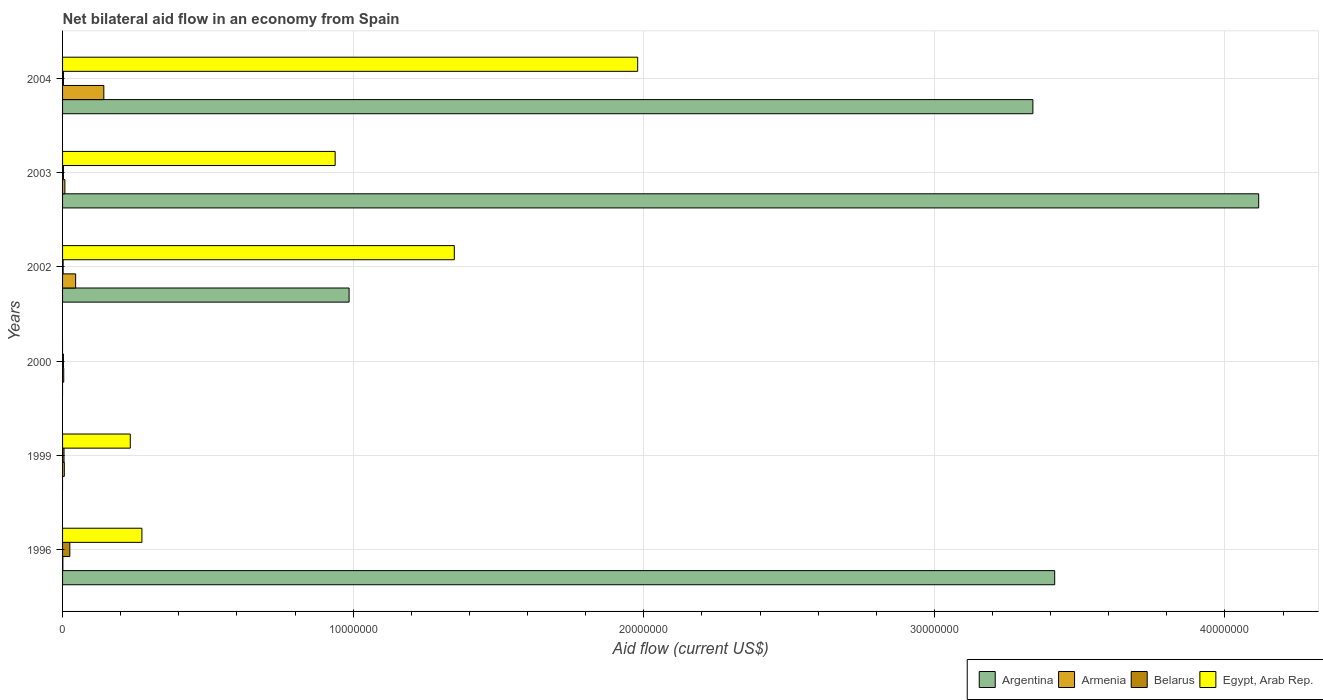How many different coloured bars are there?
Offer a very short reply. 4. Are the number of bars per tick equal to the number of legend labels?
Make the answer very short. No. How many bars are there on the 2nd tick from the bottom?
Provide a short and direct response. 3. What is the net bilateral aid flow in Belarus in 2004?
Your response must be concise. 3.00e+04. Across all years, what is the maximum net bilateral aid flow in Armenia?
Offer a terse response. 1.42e+06. In which year was the net bilateral aid flow in Egypt, Arab Rep. maximum?
Your answer should be compact. 2004. What is the total net bilateral aid flow in Egypt, Arab Rep. in the graph?
Provide a short and direct response. 4.77e+07. What is the difference between the net bilateral aid flow in Egypt, Arab Rep. in 1996 and that in 2003?
Provide a succinct answer. -6.65e+06. What is the difference between the net bilateral aid flow in Argentina in 2000 and the net bilateral aid flow in Belarus in 2003?
Provide a succinct answer. -3.00e+04. What is the average net bilateral aid flow in Egypt, Arab Rep. per year?
Offer a very short reply. 7.95e+06. In the year 2003, what is the difference between the net bilateral aid flow in Armenia and net bilateral aid flow in Egypt, Arab Rep.?
Keep it short and to the point. -9.30e+06. What is the ratio of the net bilateral aid flow in Belarus in 1999 to that in 2003?
Your answer should be very brief. 1.67. Is the net bilateral aid flow in Armenia in 2000 less than that in 2004?
Ensure brevity in your answer.  Yes. What is the difference between the highest and the second highest net bilateral aid flow in Armenia?
Give a very brief answer. 9.70e+05. What is the difference between the highest and the lowest net bilateral aid flow in Egypt, Arab Rep.?
Give a very brief answer. 1.98e+07. In how many years, is the net bilateral aid flow in Armenia greater than the average net bilateral aid flow in Armenia taken over all years?
Provide a short and direct response. 2. Is the sum of the net bilateral aid flow in Egypt, Arab Rep. in 1996 and 2003 greater than the maximum net bilateral aid flow in Argentina across all years?
Your response must be concise. No. Is it the case that in every year, the sum of the net bilateral aid flow in Belarus and net bilateral aid flow in Egypt, Arab Rep. is greater than the sum of net bilateral aid flow in Argentina and net bilateral aid flow in Armenia?
Provide a short and direct response. No. How many bars are there?
Ensure brevity in your answer.  21. Are all the bars in the graph horizontal?
Ensure brevity in your answer.  Yes. How many years are there in the graph?
Provide a short and direct response. 6. Are the values on the major ticks of X-axis written in scientific E-notation?
Make the answer very short. No. Does the graph contain any zero values?
Offer a very short reply. Yes. Where does the legend appear in the graph?
Your response must be concise. Bottom right. How many legend labels are there?
Provide a short and direct response. 4. What is the title of the graph?
Your response must be concise. Net bilateral aid flow in an economy from Spain. Does "Iraq" appear as one of the legend labels in the graph?
Provide a succinct answer. No. What is the Aid flow (current US$) in Argentina in 1996?
Offer a very short reply. 3.41e+07. What is the Aid flow (current US$) in Armenia in 1996?
Your response must be concise. 10000. What is the Aid flow (current US$) in Belarus in 1996?
Keep it short and to the point. 2.50e+05. What is the Aid flow (current US$) in Egypt, Arab Rep. in 1996?
Give a very brief answer. 2.73e+06. What is the Aid flow (current US$) of Egypt, Arab Rep. in 1999?
Offer a very short reply. 2.33e+06. What is the Aid flow (current US$) in Belarus in 2000?
Provide a succinct answer. 3.00e+04. What is the Aid flow (current US$) in Argentina in 2002?
Keep it short and to the point. 9.86e+06. What is the Aid flow (current US$) in Belarus in 2002?
Provide a short and direct response. 2.00e+04. What is the Aid flow (current US$) in Egypt, Arab Rep. in 2002?
Give a very brief answer. 1.35e+07. What is the Aid flow (current US$) of Argentina in 2003?
Ensure brevity in your answer.  4.12e+07. What is the Aid flow (current US$) of Armenia in 2003?
Ensure brevity in your answer.  8.00e+04. What is the Aid flow (current US$) of Egypt, Arab Rep. in 2003?
Offer a terse response. 9.38e+06. What is the Aid flow (current US$) in Argentina in 2004?
Your answer should be compact. 3.34e+07. What is the Aid flow (current US$) in Armenia in 2004?
Offer a terse response. 1.42e+06. What is the Aid flow (current US$) in Egypt, Arab Rep. in 2004?
Provide a short and direct response. 1.98e+07. Across all years, what is the maximum Aid flow (current US$) of Argentina?
Provide a succinct answer. 4.12e+07. Across all years, what is the maximum Aid flow (current US$) in Armenia?
Your answer should be compact. 1.42e+06. Across all years, what is the maximum Aid flow (current US$) of Belarus?
Provide a short and direct response. 2.50e+05. Across all years, what is the maximum Aid flow (current US$) of Egypt, Arab Rep.?
Your answer should be compact. 1.98e+07. Across all years, what is the minimum Aid flow (current US$) in Argentina?
Offer a very short reply. 0. Across all years, what is the minimum Aid flow (current US$) of Belarus?
Offer a very short reply. 2.00e+04. What is the total Aid flow (current US$) of Argentina in the graph?
Your answer should be very brief. 1.19e+08. What is the total Aid flow (current US$) of Armenia in the graph?
Keep it short and to the point. 2.06e+06. What is the total Aid flow (current US$) in Egypt, Arab Rep. in the graph?
Provide a short and direct response. 4.77e+07. What is the difference between the Aid flow (current US$) of Armenia in 1996 and that in 1999?
Keep it short and to the point. -5.00e+04. What is the difference between the Aid flow (current US$) in Belarus in 1996 and that in 1999?
Provide a succinct answer. 2.00e+05. What is the difference between the Aid flow (current US$) in Egypt, Arab Rep. in 1996 and that in 1999?
Provide a succinct answer. 4.00e+05. What is the difference between the Aid flow (current US$) of Armenia in 1996 and that in 2000?
Give a very brief answer. -3.00e+04. What is the difference between the Aid flow (current US$) in Belarus in 1996 and that in 2000?
Offer a very short reply. 2.20e+05. What is the difference between the Aid flow (current US$) in Argentina in 1996 and that in 2002?
Give a very brief answer. 2.43e+07. What is the difference between the Aid flow (current US$) of Armenia in 1996 and that in 2002?
Your answer should be compact. -4.40e+05. What is the difference between the Aid flow (current US$) in Egypt, Arab Rep. in 1996 and that in 2002?
Give a very brief answer. -1.08e+07. What is the difference between the Aid flow (current US$) of Argentina in 1996 and that in 2003?
Your answer should be very brief. -7.02e+06. What is the difference between the Aid flow (current US$) of Armenia in 1996 and that in 2003?
Make the answer very short. -7.00e+04. What is the difference between the Aid flow (current US$) of Belarus in 1996 and that in 2003?
Provide a succinct answer. 2.20e+05. What is the difference between the Aid flow (current US$) in Egypt, Arab Rep. in 1996 and that in 2003?
Your answer should be very brief. -6.65e+06. What is the difference between the Aid flow (current US$) in Argentina in 1996 and that in 2004?
Provide a short and direct response. 7.50e+05. What is the difference between the Aid flow (current US$) of Armenia in 1996 and that in 2004?
Your response must be concise. -1.41e+06. What is the difference between the Aid flow (current US$) in Egypt, Arab Rep. in 1996 and that in 2004?
Offer a terse response. -1.71e+07. What is the difference between the Aid flow (current US$) of Armenia in 1999 and that in 2002?
Ensure brevity in your answer.  -3.90e+05. What is the difference between the Aid flow (current US$) of Egypt, Arab Rep. in 1999 and that in 2002?
Your answer should be very brief. -1.12e+07. What is the difference between the Aid flow (current US$) in Egypt, Arab Rep. in 1999 and that in 2003?
Keep it short and to the point. -7.05e+06. What is the difference between the Aid flow (current US$) in Armenia in 1999 and that in 2004?
Offer a very short reply. -1.36e+06. What is the difference between the Aid flow (current US$) of Egypt, Arab Rep. in 1999 and that in 2004?
Give a very brief answer. -1.75e+07. What is the difference between the Aid flow (current US$) of Armenia in 2000 and that in 2002?
Provide a short and direct response. -4.10e+05. What is the difference between the Aid flow (current US$) of Armenia in 2000 and that in 2003?
Offer a very short reply. -4.00e+04. What is the difference between the Aid flow (current US$) of Armenia in 2000 and that in 2004?
Your answer should be very brief. -1.38e+06. What is the difference between the Aid flow (current US$) in Argentina in 2002 and that in 2003?
Your answer should be compact. -3.13e+07. What is the difference between the Aid flow (current US$) in Armenia in 2002 and that in 2003?
Keep it short and to the point. 3.70e+05. What is the difference between the Aid flow (current US$) of Egypt, Arab Rep. in 2002 and that in 2003?
Your response must be concise. 4.10e+06. What is the difference between the Aid flow (current US$) in Argentina in 2002 and that in 2004?
Your response must be concise. -2.35e+07. What is the difference between the Aid flow (current US$) in Armenia in 2002 and that in 2004?
Your answer should be compact. -9.70e+05. What is the difference between the Aid flow (current US$) of Belarus in 2002 and that in 2004?
Ensure brevity in your answer.  -10000. What is the difference between the Aid flow (current US$) of Egypt, Arab Rep. in 2002 and that in 2004?
Keep it short and to the point. -6.31e+06. What is the difference between the Aid flow (current US$) in Argentina in 2003 and that in 2004?
Offer a terse response. 7.77e+06. What is the difference between the Aid flow (current US$) in Armenia in 2003 and that in 2004?
Your answer should be compact. -1.34e+06. What is the difference between the Aid flow (current US$) in Egypt, Arab Rep. in 2003 and that in 2004?
Keep it short and to the point. -1.04e+07. What is the difference between the Aid flow (current US$) in Argentina in 1996 and the Aid flow (current US$) in Armenia in 1999?
Keep it short and to the point. 3.41e+07. What is the difference between the Aid flow (current US$) in Argentina in 1996 and the Aid flow (current US$) in Belarus in 1999?
Your response must be concise. 3.41e+07. What is the difference between the Aid flow (current US$) of Argentina in 1996 and the Aid flow (current US$) of Egypt, Arab Rep. in 1999?
Give a very brief answer. 3.18e+07. What is the difference between the Aid flow (current US$) of Armenia in 1996 and the Aid flow (current US$) of Egypt, Arab Rep. in 1999?
Your answer should be very brief. -2.32e+06. What is the difference between the Aid flow (current US$) in Belarus in 1996 and the Aid flow (current US$) in Egypt, Arab Rep. in 1999?
Provide a short and direct response. -2.08e+06. What is the difference between the Aid flow (current US$) of Argentina in 1996 and the Aid flow (current US$) of Armenia in 2000?
Offer a terse response. 3.41e+07. What is the difference between the Aid flow (current US$) in Argentina in 1996 and the Aid flow (current US$) in Belarus in 2000?
Offer a very short reply. 3.41e+07. What is the difference between the Aid flow (current US$) in Armenia in 1996 and the Aid flow (current US$) in Belarus in 2000?
Make the answer very short. -2.00e+04. What is the difference between the Aid flow (current US$) in Argentina in 1996 and the Aid flow (current US$) in Armenia in 2002?
Make the answer very short. 3.37e+07. What is the difference between the Aid flow (current US$) in Argentina in 1996 and the Aid flow (current US$) in Belarus in 2002?
Offer a very short reply. 3.41e+07. What is the difference between the Aid flow (current US$) in Argentina in 1996 and the Aid flow (current US$) in Egypt, Arab Rep. in 2002?
Your answer should be very brief. 2.07e+07. What is the difference between the Aid flow (current US$) in Armenia in 1996 and the Aid flow (current US$) in Belarus in 2002?
Offer a terse response. -10000. What is the difference between the Aid flow (current US$) in Armenia in 1996 and the Aid flow (current US$) in Egypt, Arab Rep. in 2002?
Offer a terse response. -1.35e+07. What is the difference between the Aid flow (current US$) in Belarus in 1996 and the Aid flow (current US$) in Egypt, Arab Rep. in 2002?
Provide a short and direct response. -1.32e+07. What is the difference between the Aid flow (current US$) in Argentina in 1996 and the Aid flow (current US$) in Armenia in 2003?
Your answer should be very brief. 3.41e+07. What is the difference between the Aid flow (current US$) in Argentina in 1996 and the Aid flow (current US$) in Belarus in 2003?
Give a very brief answer. 3.41e+07. What is the difference between the Aid flow (current US$) of Argentina in 1996 and the Aid flow (current US$) of Egypt, Arab Rep. in 2003?
Your answer should be very brief. 2.48e+07. What is the difference between the Aid flow (current US$) in Armenia in 1996 and the Aid flow (current US$) in Egypt, Arab Rep. in 2003?
Your response must be concise. -9.37e+06. What is the difference between the Aid flow (current US$) of Belarus in 1996 and the Aid flow (current US$) of Egypt, Arab Rep. in 2003?
Offer a very short reply. -9.13e+06. What is the difference between the Aid flow (current US$) in Argentina in 1996 and the Aid flow (current US$) in Armenia in 2004?
Offer a terse response. 3.27e+07. What is the difference between the Aid flow (current US$) of Argentina in 1996 and the Aid flow (current US$) of Belarus in 2004?
Give a very brief answer. 3.41e+07. What is the difference between the Aid flow (current US$) of Argentina in 1996 and the Aid flow (current US$) of Egypt, Arab Rep. in 2004?
Offer a very short reply. 1.44e+07. What is the difference between the Aid flow (current US$) of Armenia in 1996 and the Aid flow (current US$) of Belarus in 2004?
Give a very brief answer. -2.00e+04. What is the difference between the Aid flow (current US$) in Armenia in 1996 and the Aid flow (current US$) in Egypt, Arab Rep. in 2004?
Make the answer very short. -1.98e+07. What is the difference between the Aid flow (current US$) of Belarus in 1996 and the Aid flow (current US$) of Egypt, Arab Rep. in 2004?
Offer a terse response. -1.95e+07. What is the difference between the Aid flow (current US$) of Armenia in 1999 and the Aid flow (current US$) of Belarus in 2000?
Provide a short and direct response. 3.00e+04. What is the difference between the Aid flow (current US$) in Armenia in 1999 and the Aid flow (current US$) in Belarus in 2002?
Provide a short and direct response. 4.00e+04. What is the difference between the Aid flow (current US$) of Armenia in 1999 and the Aid flow (current US$) of Egypt, Arab Rep. in 2002?
Provide a short and direct response. -1.34e+07. What is the difference between the Aid flow (current US$) of Belarus in 1999 and the Aid flow (current US$) of Egypt, Arab Rep. in 2002?
Offer a terse response. -1.34e+07. What is the difference between the Aid flow (current US$) in Armenia in 1999 and the Aid flow (current US$) in Egypt, Arab Rep. in 2003?
Provide a succinct answer. -9.32e+06. What is the difference between the Aid flow (current US$) of Belarus in 1999 and the Aid flow (current US$) of Egypt, Arab Rep. in 2003?
Keep it short and to the point. -9.33e+06. What is the difference between the Aid flow (current US$) of Armenia in 1999 and the Aid flow (current US$) of Belarus in 2004?
Your answer should be compact. 3.00e+04. What is the difference between the Aid flow (current US$) of Armenia in 1999 and the Aid flow (current US$) of Egypt, Arab Rep. in 2004?
Your answer should be compact. -1.97e+07. What is the difference between the Aid flow (current US$) of Belarus in 1999 and the Aid flow (current US$) of Egypt, Arab Rep. in 2004?
Ensure brevity in your answer.  -1.97e+07. What is the difference between the Aid flow (current US$) of Armenia in 2000 and the Aid flow (current US$) of Egypt, Arab Rep. in 2002?
Offer a very short reply. -1.34e+07. What is the difference between the Aid flow (current US$) in Belarus in 2000 and the Aid flow (current US$) in Egypt, Arab Rep. in 2002?
Offer a terse response. -1.34e+07. What is the difference between the Aid flow (current US$) in Armenia in 2000 and the Aid flow (current US$) in Belarus in 2003?
Your response must be concise. 10000. What is the difference between the Aid flow (current US$) in Armenia in 2000 and the Aid flow (current US$) in Egypt, Arab Rep. in 2003?
Give a very brief answer. -9.34e+06. What is the difference between the Aid flow (current US$) in Belarus in 2000 and the Aid flow (current US$) in Egypt, Arab Rep. in 2003?
Your response must be concise. -9.35e+06. What is the difference between the Aid flow (current US$) of Armenia in 2000 and the Aid flow (current US$) of Belarus in 2004?
Give a very brief answer. 10000. What is the difference between the Aid flow (current US$) of Armenia in 2000 and the Aid flow (current US$) of Egypt, Arab Rep. in 2004?
Provide a short and direct response. -1.98e+07. What is the difference between the Aid flow (current US$) of Belarus in 2000 and the Aid flow (current US$) of Egypt, Arab Rep. in 2004?
Offer a terse response. -1.98e+07. What is the difference between the Aid flow (current US$) of Argentina in 2002 and the Aid flow (current US$) of Armenia in 2003?
Give a very brief answer. 9.78e+06. What is the difference between the Aid flow (current US$) of Argentina in 2002 and the Aid flow (current US$) of Belarus in 2003?
Your response must be concise. 9.83e+06. What is the difference between the Aid flow (current US$) of Armenia in 2002 and the Aid flow (current US$) of Belarus in 2003?
Ensure brevity in your answer.  4.20e+05. What is the difference between the Aid flow (current US$) of Armenia in 2002 and the Aid flow (current US$) of Egypt, Arab Rep. in 2003?
Make the answer very short. -8.93e+06. What is the difference between the Aid flow (current US$) in Belarus in 2002 and the Aid flow (current US$) in Egypt, Arab Rep. in 2003?
Provide a short and direct response. -9.36e+06. What is the difference between the Aid flow (current US$) in Argentina in 2002 and the Aid flow (current US$) in Armenia in 2004?
Provide a succinct answer. 8.44e+06. What is the difference between the Aid flow (current US$) in Argentina in 2002 and the Aid flow (current US$) in Belarus in 2004?
Provide a succinct answer. 9.83e+06. What is the difference between the Aid flow (current US$) in Argentina in 2002 and the Aid flow (current US$) in Egypt, Arab Rep. in 2004?
Offer a very short reply. -9.93e+06. What is the difference between the Aid flow (current US$) of Armenia in 2002 and the Aid flow (current US$) of Egypt, Arab Rep. in 2004?
Provide a succinct answer. -1.93e+07. What is the difference between the Aid flow (current US$) of Belarus in 2002 and the Aid flow (current US$) of Egypt, Arab Rep. in 2004?
Offer a very short reply. -1.98e+07. What is the difference between the Aid flow (current US$) in Argentina in 2003 and the Aid flow (current US$) in Armenia in 2004?
Give a very brief answer. 3.97e+07. What is the difference between the Aid flow (current US$) in Argentina in 2003 and the Aid flow (current US$) in Belarus in 2004?
Ensure brevity in your answer.  4.11e+07. What is the difference between the Aid flow (current US$) of Argentina in 2003 and the Aid flow (current US$) of Egypt, Arab Rep. in 2004?
Offer a terse response. 2.14e+07. What is the difference between the Aid flow (current US$) in Armenia in 2003 and the Aid flow (current US$) in Belarus in 2004?
Provide a short and direct response. 5.00e+04. What is the difference between the Aid flow (current US$) in Armenia in 2003 and the Aid flow (current US$) in Egypt, Arab Rep. in 2004?
Your answer should be very brief. -1.97e+07. What is the difference between the Aid flow (current US$) of Belarus in 2003 and the Aid flow (current US$) of Egypt, Arab Rep. in 2004?
Provide a short and direct response. -1.98e+07. What is the average Aid flow (current US$) of Argentina per year?
Keep it short and to the point. 1.98e+07. What is the average Aid flow (current US$) in Armenia per year?
Your answer should be very brief. 3.43e+05. What is the average Aid flow (current US$) of Belarus per year?
Ensure brevity in your answer.  6.83e+04. What is the average Aid flow (current US$) in Egypt, Arab Rep. per year?
Keep it short and to the point. 7.95e+06. In the year 1996, what is the difference between the Aid flow (current US$) of Argentina and Aid flow (current US$) of Armenia?
Your answer should be compact. 3.41e+07. In the year 1996, what is the difference between the Aid flow (current US$) in Argentina and Aid flow (current US$) in Belarus?
Offer a very short reply. 3.39e+07. In the year 1996, what is the difference between the Aid flow (current US$) in Argentina and Aid flow (current US$) in Egypt, Arab Rep.?
Provide a succinct answer. 3.14e+07. In the year 1996, what is the difference between the Aid flow (current US$) of Armenia and Aid flow (current US$) of Egypt, Arab Rep.?
Offer a terse response. -2.72e+06. In the year 1996, what is the difference between the Aid flow (current US$) of Belarus and Aid flow (current US$) of Egypt, Arab Rep.?
Ensure brevity in your answer.  -2.48e+06. In the year 1999, what is the difference between the Aid flow (current US$) of Armenia and Aid flow (current US$) of Egypt, Arab Rep.?
Offer a terse response. -2.27e+06. In the year 1999, what is the difference between the Aid flow (current US$) in Belarus and Aid flow (current US$) in Egypt, Arab Rep.?
Your answer should be compact. -2.28e+06. In the year 2000, what is the difference between the Aid flow (current US$) of Armenia and Aid flow (current US$) of Belarus?
Your answer should be very brief. 10000. In the year 2002, what is the difference between the Aid flow (current US$) of Argentina and Aid flow (current US$) of Armenia?
Your response must be concise. 9.41e+06. In the year 2002, what is the difference between the Aid flow (current US$) in Argentina and Aid flow (current US$) in Belarus?
Make the answer very short. 9.84e+06. In the year 2002, what is the difference between the Aid flow (current US$) of Argentina and Aid flow (current US$) of Egypt, Arab Rep.?
Offer a very short reply. -3.62e+06. In the year 2002, what is the difference between the Aid flow (current US$) of Armenia and Aid flow (current US$) of Egypt, Arab Rep.?
Offer a terse response. -1.30e+07. In the year 2002, what is the difference between the Aid flow (current US$) of Belarus and Aid flow (current US$) of Egypt, Arab Rep.?
Provide a succinct answer. -1.35e+07. In the year 2003, what is the difference between the Aid flow (current US$) of Argentina and Aid flow (current US$) of Armenia?
Your response must be concise. 4.11e+07. In the year 2003, what is the difference between the Aid flow (current US$) of Argentina and Aid flow (current US$) of Belarus?
Keep it short and to the point. 4.11e+07. In the year 2003, what is the difference between the Aid flow (current US$) in Argentina and Aid flow (current US$) in Egypt, Arab Rep.?
Your answer should be compact. 3.18e+07. In the year 2003, what is the difference between the Aid flow (current US$) in Armenia and Aid flow (current US$) in Belarus?
Offer a very short reply. 5.00e+04. In the year 2003, what is the difference between the Aid flow (current US$) of Armenia and Aid flow (current US$) of Egypt, Arab Rep.?
Make the answer very short. -9.30e+06. In the year 2003, what is the difference between the Aid flow (current US$) of Belarus and Aid flow (current US$) of Egypt, Arab Rep.?
Provide a succinct answer. -9.35e+06. In the year 2004, what is the difference between the Aid flow (current US$) in Argentina and Aid flow (current US$) in Armenia?
Your response must be concise. 3.20e+07. In the year 2004, what is the difference between the Aid flow (current US$) in Argentina and Aid flow (current US$) in Belarus?
Provide a short and direct response. 3.34e+07. In the year 2004, what is the difference between the Aid flow (current US$) in Argentina and Aid flow (current US$) in Egypt, Arab Rep.?
Provide a short and direct response. 1.36e+07. In the year 2004, what is the difference between the Aid flow (current US$) of Armenia and Aid flow (current US$) of Belarus?
Keep it short and to the point. 1.39e+06. In the year 2004, what is the difference between the Aid flow (current US$) of Armenia and Aid flow (current US$) of Egypt, Arab Rep.?
Your answer should be compact. -1.84e+07. In the year 2004, what is the difference between the Aid flow (current US$) of Belarus and Aid flow (current US$) of Egypt, Arab Rep.?
Ensure brevity in your answer.  -1.98e+07. What is the ratio of the Aid flow (current US$) of Egypt, Arab Rep. in 1996 to that in 1999?
Offer a very short reply. 1.17. What is the ratio of the Aid flow (current US$) of Belarus in 1996 to that in 2000?
Offer a terse response. 8.33. What is the ratio of the Aid flow (current US$) of Argentina in 1996 to that in 2002?
Give a very brief answer. 3.46. What is the ratio of the Aid flow (current US$) of Armenia in 1996 to that in 2002?
Keep it short and to the point. 0.02. What is the ratio of the Aid flow (current US$) in Belarus in 1996 to that in 2002?
Provide a succinct answer. 12.5. What is the ratio of the Aid flow (current US$) in Egypt, Arab Rep. in 1996 to that in 2002?
Give a very brief answer. 0.2. What is the ratio of the Aid flow (current US$) in Argentina in 1996 to that in 2003?
Ensure brevity in your answer.  0.83. What is the ratio of the Aid flow (current US$) in Belarus in 1996 to that in 2003?
Make the answer very short. 8.33. What is the ratio of the Aid flow (current US$) in Egypt, Arab Rep. in 1996 to that in 2003?
Provide a short and direct response. 0.29. What is the ratio of the Aid flow (current US$) of Argentina in 1996 to that in 2004?
Your answer should be compact. 1.02. What is the ratio of the Aid flow (current US$) in Armenia in 1996 to that in 2004?
Provide a short and direct response. 0.01. What is the ratio of the Aid flow (current US$) in Belarus in 1996 to that in 2004?
Provide a succinct answer. 8.33. What is the ratio of the Aid flow (current US$) in Egypt, Arab Rep. in 1996 to that in 2004?
Make the answer very short. 0.14. What is the ratio of the Aid flow (current US$) in Armenia in 1999 to that in 2002?
Offer a very short reply. 0.13. What is the ratio of the Aid flow (current US$) of Belarus in 1999 to that in 2002?
Provide a succinct answer. 2.5. What is the ratio of the Aid flow (current US$) in Egypt, Arab Rep. in 1999 to that in 2002?
Your answer should be compact. 0.17. What is the ratio of the Aid flow (current US$) of Armenia in 1999 to that in 2003?
Your response must be concise. 0.75. What is the ratio of the Aid flow (current US$) in Egypt, Arab Rep. in 1999 to that in 2003?
Make the answer very short. 0.25. What is the ratio of the Aid flow (current US$) of Armenia in 1999 to that in 2004?
Provide a succinct answer. 0.04. What is the ratio of the Aid flow (current US$) of Belarus in 1999 to that in 2004?
Offer a terse response. 1.67. What is the ratio of the Aid flow (current US$) of Egypt, Arab Rep. in 1999 to that in 2004?
Offer a very short reply. 0.12. What is the ratio of the Aid flow (current US$) of Armenia in 2000 to that in 2002?
Offer a very short reply. 0.09. What is the ratio of the Aid flow (current US$) in Armenia in 2000 to that in 2003?
Provide a succinct answer. 0.5. What is the ratio of the Aid flow (current US$) of Belarus in 2000 to that in 2003?
Give a very brief answer. 1. What is the ratio of the Aid flow (current US$) of Armenia in 2000 to that in 2004?
Offer a very short reply. 0.03. What is the ratio of the Aid flow (current US$) in Belarus in 2000 to that in 2004?
Your response must be concise. 1. What is the ratio of the Aid flow (current US$) in Argentina in 2002 to that in 2003?
Provide a succinct answer. 0.24. What is the ratio of the Aid flow (current US$) in Armenia in 2002 to that in 2003?
Provide a succinct answer. 5.62. What is the ratio of the Aid flow (current US$) in Belarus in 2002 to that in 2003?
Provide a succinct answer. 0.67. What is the ratio of the Aid flow (current US$) of Egypt, Arab Rep. in 2002 to that in 2003?
Ensure brevity in your answer.  1.44. What is the ratio of the Aid flow (current US$) of Argentina in 2002 to that in 2004?
Keep it short and to the point. 0.3. What is the ratio of the Aid flow (current US$) of Armenia in 2002 to that in 2004?
Provide a succinct answer. 0.32. What is the ratio of the Aid flow (current US$) in Egypt, Arab Rep. in 2002 to that in 2004?
Keep it short and to the point. 0.68. What is the ratio of the Aid flow (current US$) in Argentina in 2003 to that in 2004?
Offer a very short reply. 1.23. What is the ratio of the Aid flow (current US$) of Armenia in 2003 to that in 2004?
Your answer should be very brief. 0.06. What is the ratio of the Aid flow (current US$) of Belarus in 2003 to that in 2004?
Give a very brief answer. 1. What is the ratio of the Aid flow (current US$) in Egypt, Arab Rep. in 2003 to that in 2004?
Make the answer very short. 0.47. What is the difference between the highest and the second highest Aid flow (current US$) of Argentina?
Give a very brief answer. 7.02e+06. What is the difference between the highest and the second highest Aid flow (current US$) of Armenia?
Your answer should be compact. 9.70e+05. What is the difference between the highest and the second highest Aid flow (current US$) in Egypt, Arab Rep.?
Offer a very short reply. 6.31e+06. What is the difference between the highest and the lowest Aid flow (current US$) of Argentina?
Ensure brevity in your answer.  4.12e+07. What is the difference between the highest and the lowest Aid flow (current US$) in Armenia?
Make the answer very short. 1.41e+06. What is the difference between the highest and the lowest Aid flow (current US$) in Belarus?
Your answer should be very brief. 2.30e+05. What is the difference between the highest and the lowest Aid flow (current US$) of Egypt, Arab Rep.?
Offer a very short reply. 1.98e+07. 